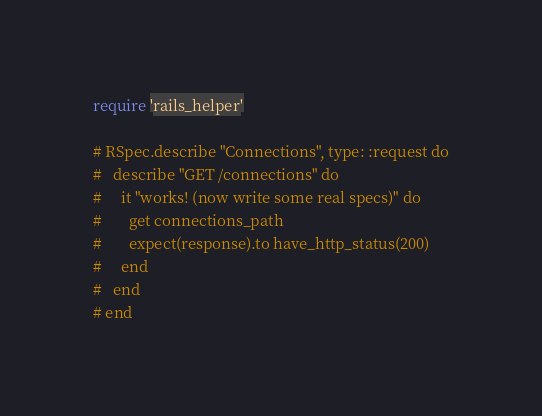Convert code to text. <code><loc_0><loc_0><loc_500><loc_500><_Ruby_>require 'rails_helper'

# RSpec.describe "Connections", type: :request do
#   describe "GET /connections" do
#     it "works! (now write some real specs)" do
#       get connections_path
#       expect(response).to have_http_status(200)
#     end
#   end
# end
</code> 